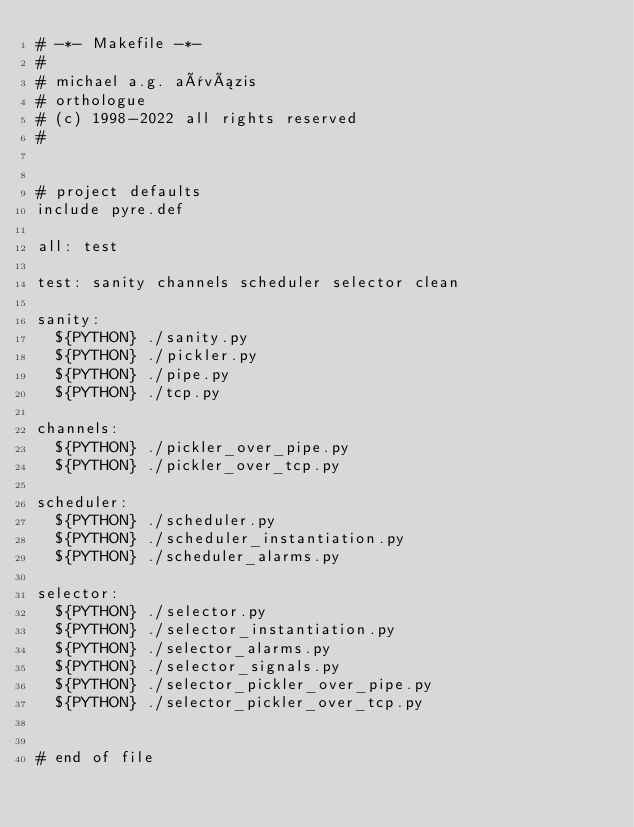Convert code to text. <code><loc_0><loc_0><loc_500><loc_500><_ObjectiveC_># -*- Makefile -*-
#
# michael a.g. aïvázis
# orthologue
# (c) 1998-2022 all rights reserved
#


# project defaults
include pyre.def

all: test

test: sanity channels scheduler selector clean

sanity:
	${PYTHON} ./sanity.py
	${PYTHON} ./pickler.py
	${PYTHON} ./pipe.py
	${PYTHON} ./tcp.py

channels:
	${PYTHON} ./pickler_over_pipe.py
	${PYTHON} ./pickler_over_tcp.py

scheduler:
	${PYTHON} ./scheduler.py
	${PYTHON} ./scheduler_instantiation.py
	${PYTHON} ./scheduler_alarms.py

selector:
	${PYTHON} ./selector.py
	${PYTHON} ./selector_instantiation.py
	${PYTHON} ./selector_alarms.py
	${PYTHON} ./selector_signals.py
	${PYTHON} ./selector_pickler_over_pipe.py
	${PYTHON} ./selector_pickler_over_tcp.py


# end of file
</code> 